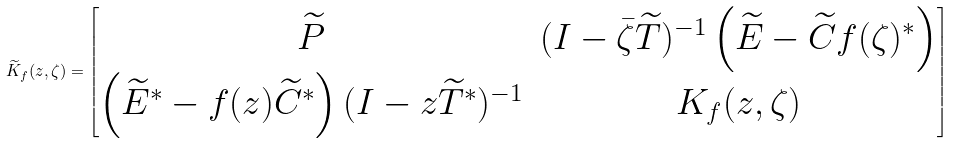Convert formula to latex. <formula><loc_0><loc_0><loc_500><loc_500>\widetilde { K } _ { f } ( z , \zeta ) = \begin{bmatrix} \widetilde { P } & ( I - \bar { \zeta } \widetilde { T } ) ^ { - 1 } \left ( \widetilde { E } - \widetilde { C } f ( \zeta ) ^ { * } \right ) \\ \left ( \widetilde { E } ^ { * } - f ( z ) \widetilde { C } ^ { * } \right ) ( I - z \widetilde { T } ^ { * } ) ^ { - 1 } & K _ { f } ( z , \zeta ) \end{bmatrix}</formula> 